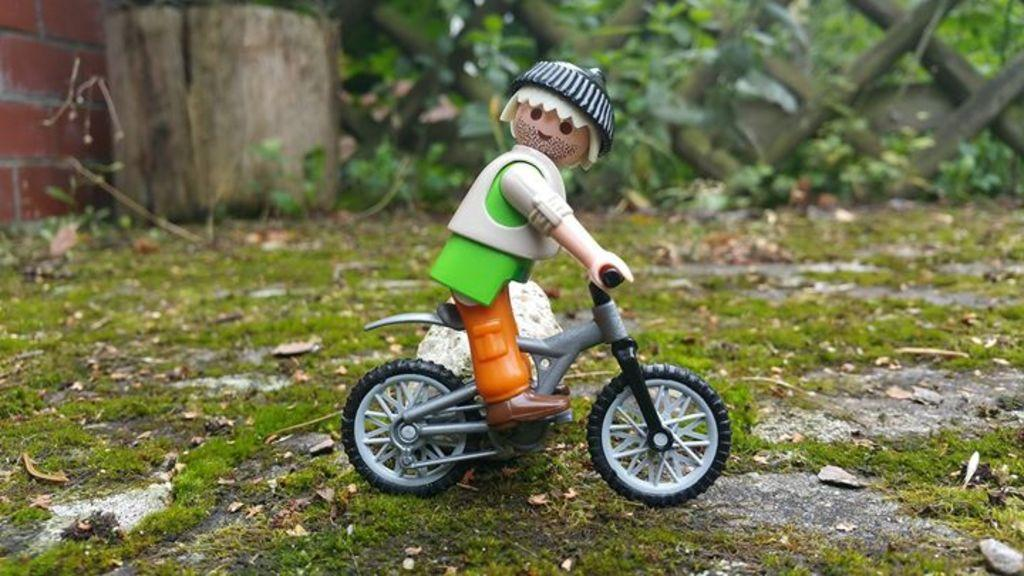What is the toy person in the image doing? The toy person is riding a toy bicycle in the image. What can be seen on the left side of the image? There is a brick wall on the left side of the image. What type of fencing is visible at the top of the image? There is wooden fencing at the top of the image. What type of vegetation is present in the image? There are plants in the image. What language is the toy person speaking in the image? Toys do not speak any language, so this question cannot be answered definitively. --- Facts: 1. There is a person holding a book in the image. 2. The book has a blue cover. 3. The person is sitting on a chair. 4. There is a table in front of the person. 5. The table has a lamp on it. Absurd Topics: elephant, ocean, dance Conversation: What is the person in the image holding? The person in the image is holding a book. What color is the book's cover? The book has a blue cover. What is the person sitting on in the image? The person is sitting on a chair. What object is on the table in front of the person? There is a lamp on the table in front of the person. Reasoning: Let's think step by step in order to produce the conversation. We start by identifying the main subject in the image, which is the person holding a book. Then, we expand the conversation to include other elements of the image, such as the book's color, the chair, and the table with a lamp. Each question is designed to elicit a specific detail about the image that is known from the provided facts. Absurd Question/Answer: Can you see an elephant swimming in the ocean in the image? No, there is no elephant or ocean present in the image. 